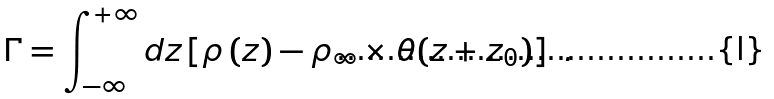<formula> <loc_0><loc_0><loc_500><loc_500>\Gamma = \int _ { - \infty } ^ { + \infty } d z \left [ \rho \left ( z \right ) - \rho _ { \infty } \times \theta ( z + z _ { 0 } ) \right ] \ .</formula> 